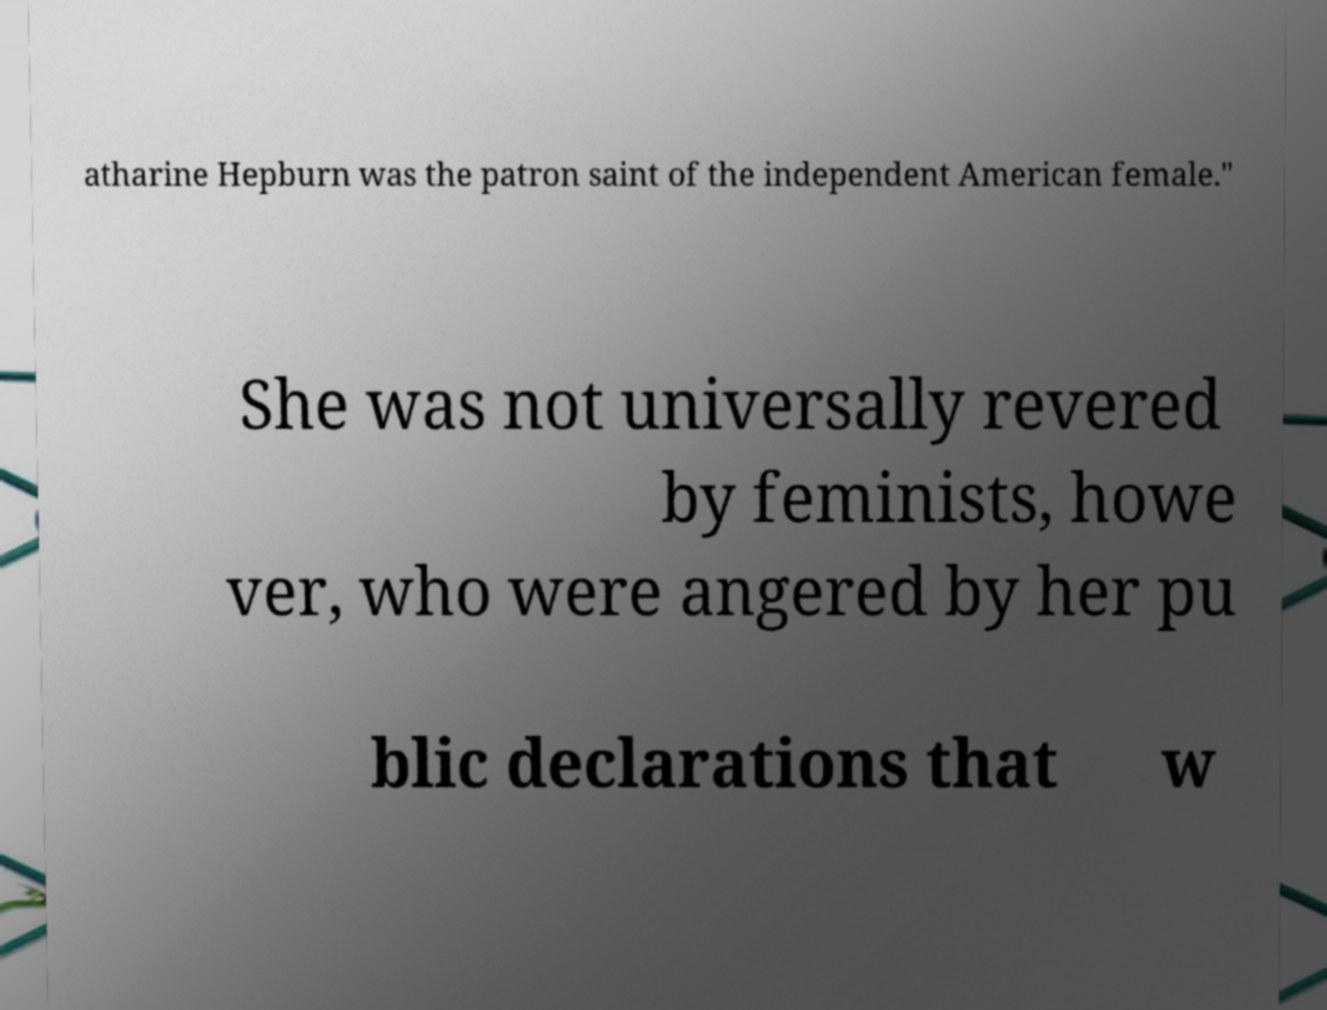Can you accurately transcribe the text from the provided image for me? atharine Hepburn was the patron saint of the independent American female." She was not universally revered by feminists, howe ver, who were angered by her pu blic declarations that w 